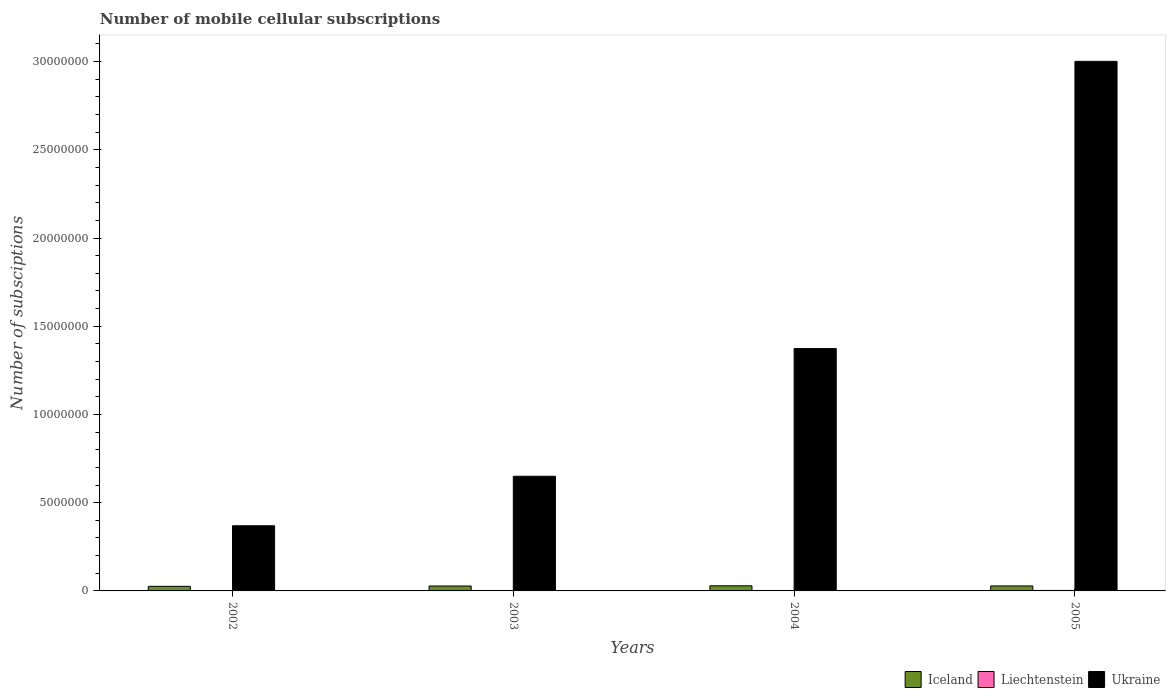How many different coloured bars are there?
Ensure brevity in your answer.  3. In how many cases, is the number of bars for a given year not equal to the number of legend labels?
Offer a very short reply. 0. What is the number of mobile cellular subscriptions in Liechtenstein in 2005?
Ensure brevity in your answer.  2.75e+04. Across all years, what is the maximum number of mobile cellular subscriptions in Ukraine?
Provide a succinct answer. 3.00e+07. Across all years, what is the minimum number of mobile cellular subscriptions in Ukraine?
Offer a terse response. 3.69e+06. What is the total number of mobile cellular subscriptions in Iceland in the graph?
Your response must be concise. 1.11e+06. What is the difference between the number of mobile cellular subscriptions in Liechtenstein in 2003 and that in 2004?
Ensure brevity in your answer.  -500. What is the difference between the number of mobile cellular subscriptions in Liechtenstein in 2003 and the number of mobile cellular subscriptions in Ukraine in 2002?
Provide a succinct answer. -3.67e+06. What is the average number of mobile cellular subscriptions in Ukraine per year?
Offer a very short reply. 1.35e+07. In the year 2002, what is the difference between the number of mobile cellular subscriptions in Liechtenstein and number of mobile cellular subscriptions in Ukraine?
Provide a succinct answer. -3.68e+06. In how many years, is the number of mobile cellular subscriptions in Iceland greater than 3000000?
Your response must be concise. 0. What is the ratio of the number of mobile cellular subscriptions in Ukraine in 2002 to that in 2004?
Offer a terse response. 0.27. Is the difference between the number of mobile cellular subscriptions in Liechtenstein in 2004 and 2005 greater than the difference between the number of mobile cellular subscriptions in Ukraine in 2004 and 2005?
Give a very brief answer. Yes. What is the difference between the highest and the second highest number of mobile cellular subscriptions in Ukraine?
Make the answer very short. 1.63e+07. What is the difference between the highest and the lowest number of mobile cellular subscriptions in Ukraine?
Your answer should be very brief. 2.63e+07. In how many years, is the number of mobile cellular subscriptions in Liechtenstein greater than the average number of mobile cellular subscriptions in Liechtenstein taken over all years?
Offer a terse response. 3. What does the 1st bar from the left in 2002 represents?
Offer a terse response. Iceland. What does the 1st bar from the right in 2002 represents?
Offer a terse response. Ukraine. Are all the bars in the graph horizontal?
Keep it short and to the point. No. Are the values on the major ticks of Y-axis written in scientific E-notation?
Your answer should be very brief. No. Does the graph contain any zero values?
Keep it short and to the point. No. How many legend labels are there?
Your response must be concise. 3. What is the title of the graph?
Ensure brevity in your answer.  Number of mobile cellular subscriptions. Does "Belarus" appear as one of the legend labels in the graph?
Your answer should be very brief. No. What is the label or title of the Y-axis?
Your response must be concise. Number of subsciptions. What is the Number of subsciptions in Iceland in 2002?
Offer a terse response. 2.60e+05. What is the Number of subsciptions in Liechtenstein in 2002?
Ensure brevity in your answer.  1.14e+04. What is the Number of subsciptions in Ukraine in 2002?
Provide a succinct answer. 3.69e+06. What is the Number of subsciptions in Iceland in 2003?
Provide a succinct answer. 2.80e+05. What is the Number of subsciptions of Liechtenstein in 2003?
Provide a short and direct response. 2.50e+04. What is the Number of subsciptions of Ukraine in 2003?
Offer a very short reply. 6.50e+06. What is the Number of subsciptions in Iceland in 2004?
Make the answer very short. 2.90e+05. What is the Number of subsciptions of Liechtenstein in 2004?
Keep it short and to the point. 2.55e+04. What is the Number of subsciptions of Ukraine in 2004?
Ensure brevity in your answer.  1.37e+07. What is the Number of subsciptions of Iceland in 2005?
Provide a short and direct response. 2.83e+05. What is the Number of subsciptions of Liechtenstein in 2005?
Ensure brevity in your answer.  2.75e+04. What is the Number of subsciptions in Ukraine in 2005?
Offer a terse response. 3.00e+07. Across all years, what is the maximum Number of subsciptions in Iceland?
Offer a very short reply. 2.90e+05. Across all years, what is the maximum Number of subsciptions in Liechtenstein?
Offer a terse response. 2.75e+04. Across all years, what is the maximum Number of subsciptions of Ukraine?
Keep it short and to the point. 3.00e+07. Across all years, what is the minimum Number of subsciptions in Iceland?
Offer a terse response. 2.60e+05. Across all years, what is the minimum Number of subsciptions of Liechtenstein?
Make the answer very short. 1.14e+04. Across all years, what is the minimum Number of subsciptions of Ukraine?
Make the answer very short. 3.69e+06. What is the total Number of subsciptions of Iceland in the graph?
Your answer should be very brief. 1.11e+06. What is the total Number of subsciptions in Liechtenstein in the graph?
Make the answer very short. 8.94e+04. What is the total Number of subsciptions of Ukraine in the graph?
Make the answer very short. 5.39e+07. What is the difference between the Number of subsciptions in Iceland in 2002 and that in 2003?
Give a very brief answer. -1.92e+04. What is the difference between the Number of subsciptions of Liechtenstein in 2002 and that in 2003?
Your answer should be very brief. -1.36e+04. What is the difference between the Number of subsciptions of Ukraine in 2002 and that in 2003?
Your response must be concise. -2.81e+06. What is the difference between the Number of subsciptions of Iceland in 2002 and that in 2004?
Keep it short and to the point. -2.96e+04. What is the difference between the Number of subsciptions in Liechtenstein in 2002 and that in 2004?
Make the answer very short. -1.41e+04. What is the difference between the Number of subsciptions of Ukraine in 2002 and that in 2004?
Your response must be concise. -1.00e+07. What is the difference between the Number of subsciptions of Iceland in 2002 and that in 2005?
Give a very brief answer. -2.27e+04. What is the difference between the Number of subsciptions in Liechtenstein in 2002 and that in 2005?
Make the answer very short. -1.61e+04. What is the difference between the Number of subsciptions in Ukraine in 2002 and that in 2005?
Offer a very short reply. -2.63e+07. What is the difference between the Number of subsciptions of Iceland in 2003 and that in 2004?
Your response must be concise. -1.04e+04. What is the difference between the Number of subsciptions of Liechtenstein in 2003 and that in 2004?
Offer a terse response. -500. What is the difference between the Number of subsciptions in Ukraine in 2003 and that in 2004?
Your answer should be compact. -7.24e+06. What is the difference between the Number of subsciptions of Iceland in 2003 and that in 2005?
Provide a short and direct response. -3438. What is the difference between the Number of subsciptions of Liechtenstein in 2003 and that in 2005?
Your answer should be very brief. -2503. What is the difference between the Number of subsciptions of Ukraine in 2003 and that in 2005?
Offer a very short reply. -2.35e+07. What is the difference between the Number of subsciptions in Iceland in 2004 and that in 2005?
Give a very brief answer. 6960. What is the difference between the Number of subsciptions in Liechtenstein in 2004 and that in 2005?
Your answer should be very brief. -2003. What is the difference between the Number of subsciptions in Ukraine in 2004 and that in 2005?
Offer a terse response. -1.63e+07. What is the difference between the Number of subsciptions of Iceland in 2002 and the Number of subsciptions of Liechtenstein in 2003?
Give a very brief answer. 2.35e+05. What is the difference between the Number of subsciptions in Iceland in 2002 and the Number of subsciptions in Ukraine in 2003?
Ensure brevity in your answer.  -6.24e+06. What is the difference between the Number of subsciptions of Liechtenstein in 2002 and the Number of subsciptions of Ukraine in 2003?
Give a very brief answer. -6.49e+06. What is the difference between the Number of subsciptions of Iceland in 2002 and the Number of subsciptions of Liechtenstein in 2004?
Your answer should be compact. 2.35e+05. What is the difference between the Number of subsciptions of Iceland in 2002 and the Number of subsciptions of Ukraine in 2004?
Your response must be concise. -1.35e+07. What is the difference between the Number of subsciptions of Liechtenstein in 2002 and the Number of subsciptions of Ukraine in 2004?
Make the answer very short. -1.37e+07. What is the difference between the Number of subsciptions of Iceland in 2002 and the Number of subsciptions of Liechtenstein in 2005?
Ensure brevity in your answer.  2.33e+05. What is the difference between the Number of subsciptions in Iceland in 2002 and the Number of subsciptions in Ukraine in 2005?
Offer a very short reply. -2.98e+07. What is the difference between the Number of subsciptions of Liechtenstein in 2002 and the Number of subsciptions of Ukraine in 2005?
Provide a short and direct response. -3.00e+07. What is the difference between the Number of subsciptions of Iceland in 2003 and the Number of subsciptions of Liechtenstein in 2004?
Offer a terse response. 2.54e+05. What is the difference between the Number of subsciptions of Iceland in 2003 and the Number of subsciptions of Ukraine in 2004?
Offer a terse response. -1.35e+07. What is the difference between the Number of subsciptions in Liechtenstein in 2003 and the Number of subsciptions in Ukraine in 2004?
Make the answer very short. -1.37e+07. What is the difference between the Number of subsciptions in Iceland in 2003 and the Number of subsciptions in Liechtenstein in 2005?
Your response must be concise. 2.52e+05. What is the difference between the Number of subsciptions of Iceland in 2003 and the Number of subsciptions of Ukraine in 2005?
Your response must be concise. -2.97e+07. What is the difference between the Number of subsciptions of Liechtenstein in 2003 and the Number of subsciptions of Ukraine in 2005?
Your response must be concise. -3.00e+07. What is the difference between the Number of subsciptions in Iceland in 2004 and the Number of subsciptions in Liechtenstein in 2005?
Your answer should be compact. 2.63e+05. What is the difference between the Number of subsciptions of Iceland in 2004 and the Number of subsciptions of Ukraine in 2005?
Ensure brevity in your answer.  -2.97e+07. What is the difference between the Number of subsciptions in Liechtenstein in 2004 and the Number of subsciptions in Ukraine in 2005?
Offer a very short reply. -3.00e+07. What is the average Number of subsciptions of Iceland per year?
Provide a short and direct response. 2.78e+05. What is the average Number of subsciptions in Liechtenstein per year?
Your response must be concise. 2.24e+04. What is the average Number of subsciptions in Ukraine per year?
Provide a succinct answer. 1.35e+07. In the year 2002, what is the difference between the Number of subsciptions in Iceland and Number of subsciptions in Liechtenstein?
Your answer should be very brief. 2.49e+05. In the year 2002, what is the difference between the Number of subsciptions of Iceland and Number of subsciptions of Ukraine?
Keep it short and to the point. -3.43e+06. In the year 2002, what is the difference between the Number of subsciptions in Liechtenstein and Number of subsciptions in Ukraine?
Provide a short and direct response. -3.68e+06. In the year 2003, what is the difference between the Number of subsciptions of Iceland and Number of subsciptions of Liechtenstein?
Provide a short and direct response. 2.55e+05. In the year 2003, what is the difference between the Number of subsciptions in Iceland and Number of subsciptions in Ukraine?
Offer a terse response. -6.22e+06. In the year 2003, what is the difference between the Number of subsciptions of Liechtenstein and Number of subsciptions of Ukraine?
Provide a succinct answer. -6.47e+06. In the year 2004, what is the difference between the Number of subsciptions in Iceland and Number of subsciptions in Liechtenstein?
Provide a short and direct response. 2.65e+05. In the year 2004, what is the difference between the Number of subsciptions of Iceland and Number of subsciptions of Ukraine?
Offer a very short reply. -1.34e+07. In the year 2004, what is the difference between the Number of subsciptions of Liechtenstein and Number of subsciptions of Ukraine?
Offer a terse response. -1.37e+07. In the year 2005, what is the difference between the Number of subsciptions in Iceland and Number of subsciptions in Liechtenstein?
Offer a terse response. 2.56e+05. In the year 2005, what is the difference between the Number of subsciptions of Iceland and Number of subsciptions of Ukraine?
Give a very brief answer. -2.97e+07. In the year 2005, what is the difference between the Number of subsciptions of Liechtenstein and Number of subsciptions of Ukraine?
Give a very brief answer. -3.00e+07. What is the ratio of the Number of subsciptions in Iceland in 2002 to that in 2003?
Make the answer very short. 0.93. What is the ratio of the Number of subsciptions of Liechtenstein in 2002 to that in 2003?
Your answer should be compact. 0.46. What is the ratio of the Number of subsciptions of Ukraine in 2002 to that in 2003?
Provide a short and direct response. 0.57. What is the ratio of the Number of subsciptions in Iceland in 2002 to that in 2004?
Provide a succinct answer. 0.9. What is the ratio of the Number of subsciptions of Liechtenstein in 2002 to that in 2004?
Offer a very short reply. 0.45. What is the ratio of the Number of subsciptions in Ukraine in 2002 to that in 2004?
Your answer should be very brief. 0.27. What is the ratio of the Number of subsciptions of Iceland in 2002 to that in 2005?
Your answer should be very brief. 0.92. What is the ratio of the Number of subsciptions in Liechtenstein in 2002 to that in 2005?
Provide a short and direct response. 0.41. What is the ratio of the Number of subsciptions in Ukraine in 2002 to that in 2005?
Your answer should be compact. 0.12. What is the ratio of the Number of subsciptions in Iceland in 2003 to that in 2004?
Your response must be concise. 0.96. What is the ratio of the Number of subsciptions in Liechtenstein in 2003 to that in 2004?
Keep it short and to the point. 0.98. What is the ratio of the Number of subsciptions of Ukraine in 2003 to that in 2004?
Offer a very short reply. 0.47. What is the ratio of the Number of subsciptions of Iceland in 2003 to that in 2005?
Give a very brief answer. 0.99. What is the ratio of the Number of subsciptions of Liechtenstein in 2003 to that in 2005?
Offer a terse response. 0.91. What is the ratio of the Number of subsciptions of Ukraine in 2003 to that in 2005?
Your response must be concise. 0.22. What is the ratio of the Number of subsciptions of Iceland in 2004 to that in 2005?
Ensure brevity in your answer.  1.02. What is the ratio of the Number of subsciptions in Liechtenstein in 2004 to that in 2005?
Ensure brevity in your answer.  0.93. What is the ratio of the Number of subsciptions in Ukraine in 2004 to that in 2005?
Make the answer very short. 0.46. What is the difference between the highest and the second highest Number of subsciptions of Iceland?
Provide a succinct answer. 6960. What is the difference between the highest and the second highest Number of subsciptions of Liechtenstein?
Provide a short and direct response. 2003. What is the difference between the highest and the second highest Number of subsciptions in Ukraine?
Keep it short and to the point. 1.63e+07. What is the difference between the highest and the lowest Number of subsciptions in Iceland?
Keep it short and to the point. 2.96e+04. What is the difference between the highest and the lowest Number of subsciptions in Liechtenstein?
Keep it short and to the point. 1.61e+04. What is the difference between the highest and the lowest Number of subsciptions in Ukraine?
Ensure brevity in your answer.  2.63e+07. 